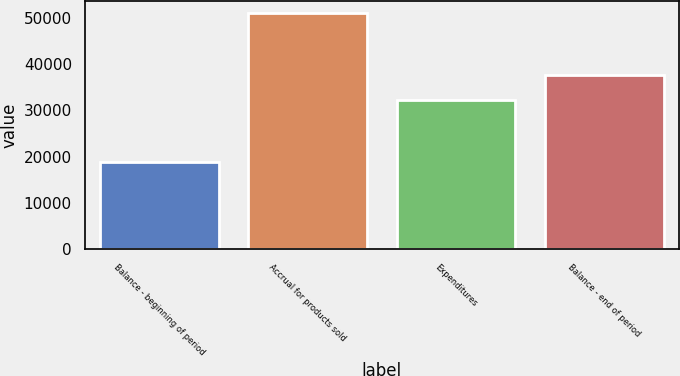<chart> <loc_0><loc_0><loc_500><loc_500><bar_chart><fcel>Balance - beginning of period<fcel>Accrual for products sold<fcel>Expenditures<fcel>Balance - end of period<nl><fcel>18817<fcel>51080<fcel>32258<fcel>37639<nl></chart> 